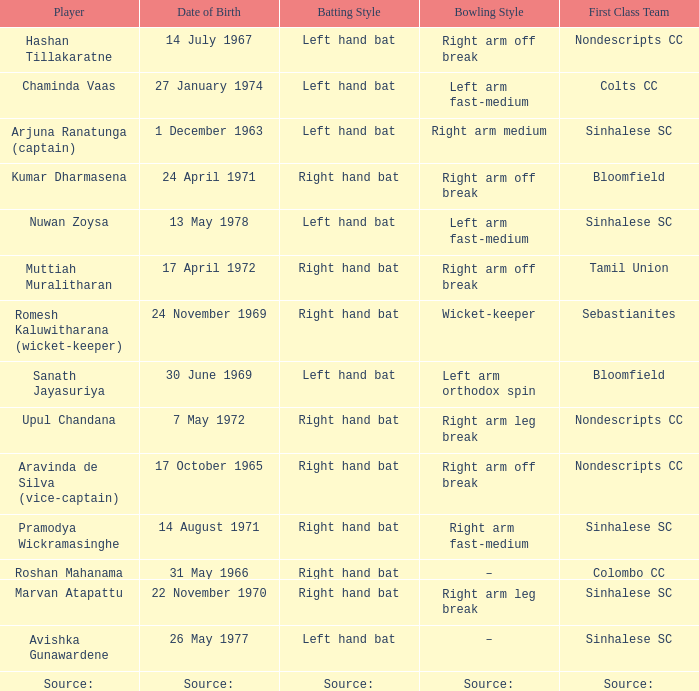When was roshan mahanama born? 31 May 1966. 